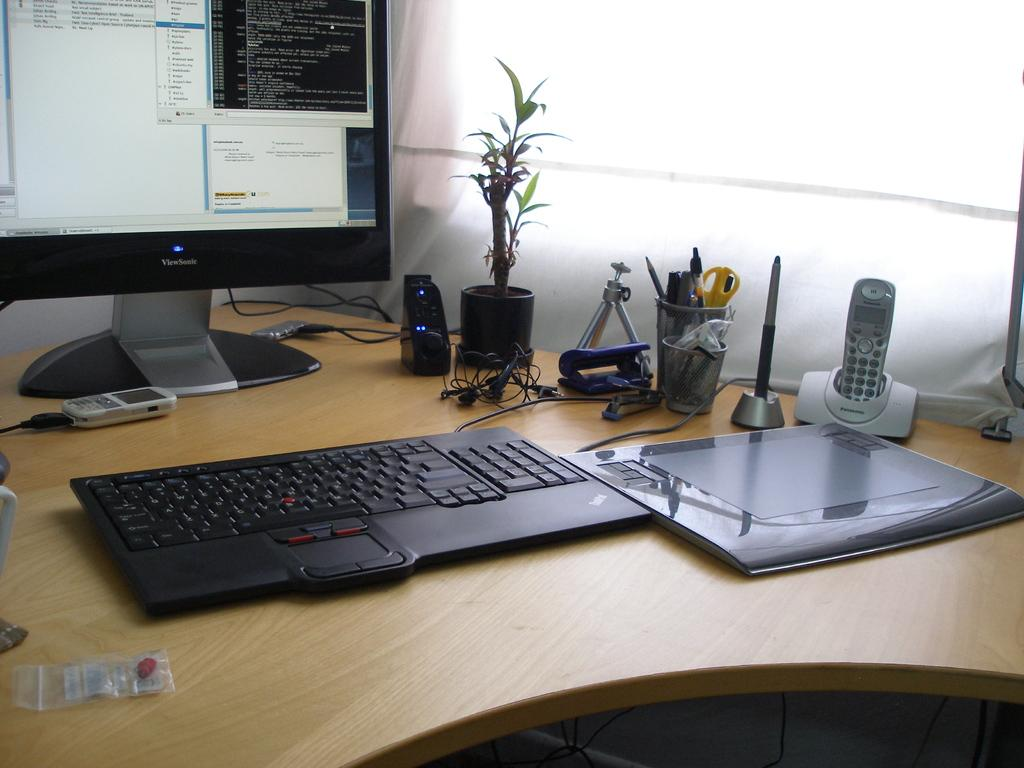What piece of furniture is visible in the image? There is a table in the image. What electronic device is placed on the table? A computer is placed on the table. What type of items can be seen on the table besides the computer? There are files, mobile phones, and accessories on the table. What can be seen in the background of the image? There is a window curtain in the background of the image. Where is the scarecrow located in the image? There is no scarecrow present in the image. How many clocks are visible in the image? There are no clocks visible in the image. 